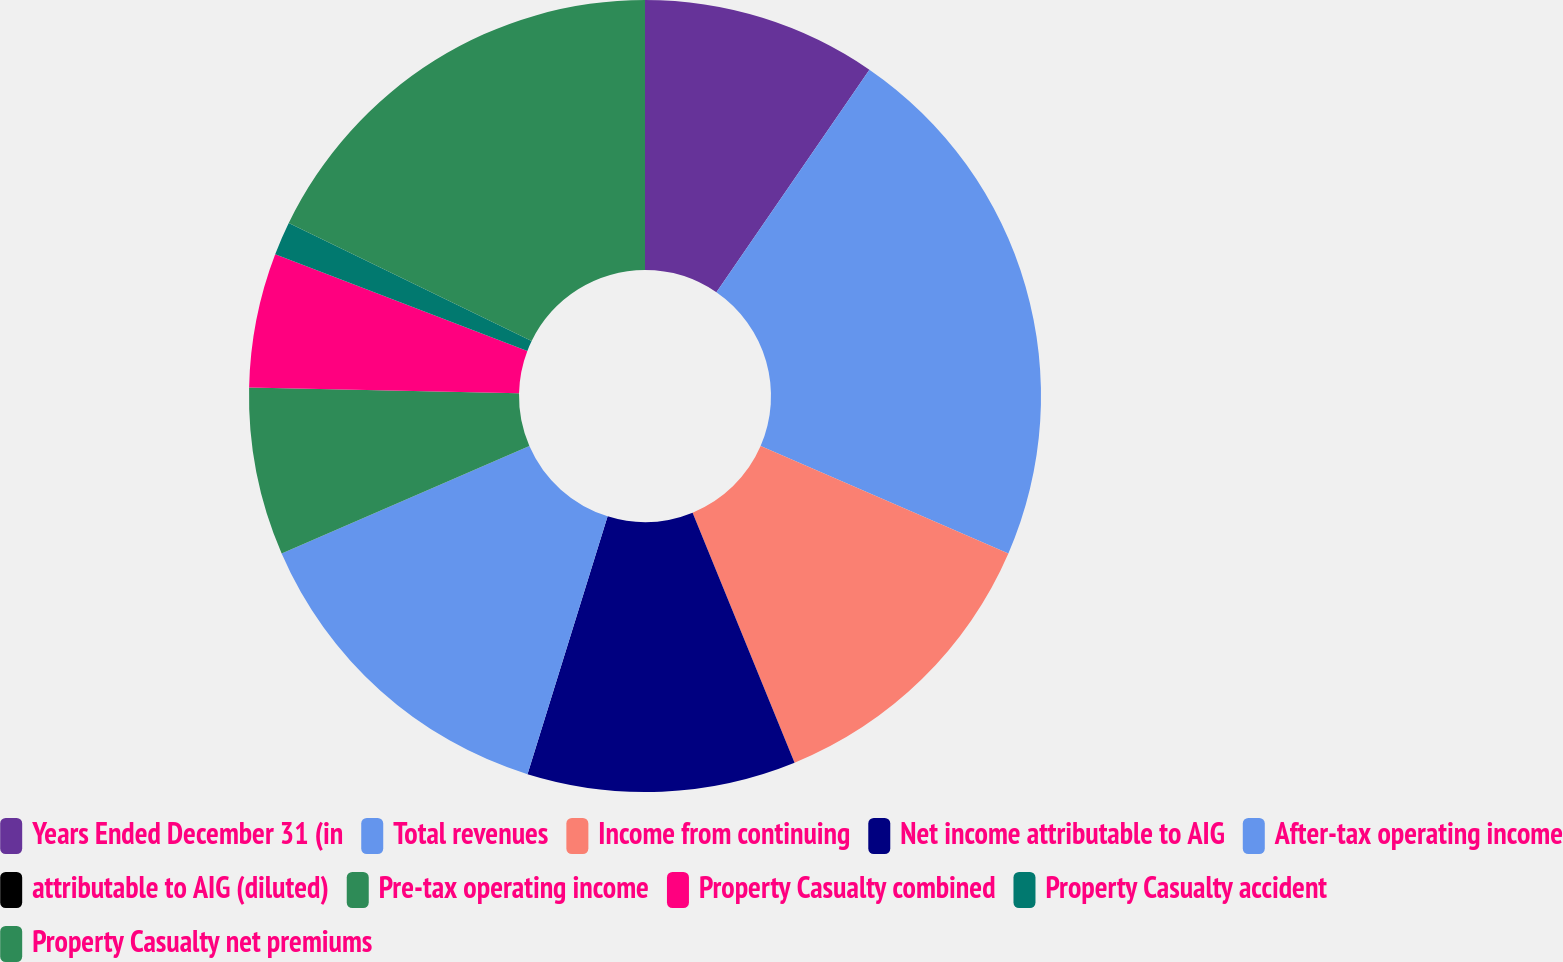Convert chart to OTSL. <chart><loc_0><loc_0><loc_500><loc_500><pie_chart><fcel>Years Ended December 31 (in<fcel>Total revenues<fcel>Income from continuing<fcel>Net income attributable to AIG<fcel>After-tax operating income<fcel>attributable to AIG (diluted)<fcel>Pre-tax operating income<fcel>Property Casualty combined<fcel>Property Casualty accident<fcel>Property Casualty net premiums<nl><fcel>9.59%<fcel>21.92%<fcel>12.33%<fcel>10.96%<fcel>13.7%<fcel>0.0%<fcel>6.85%<fcel>5.48%<fcel>1.37%<fcel>17.81%<nl></chart> 